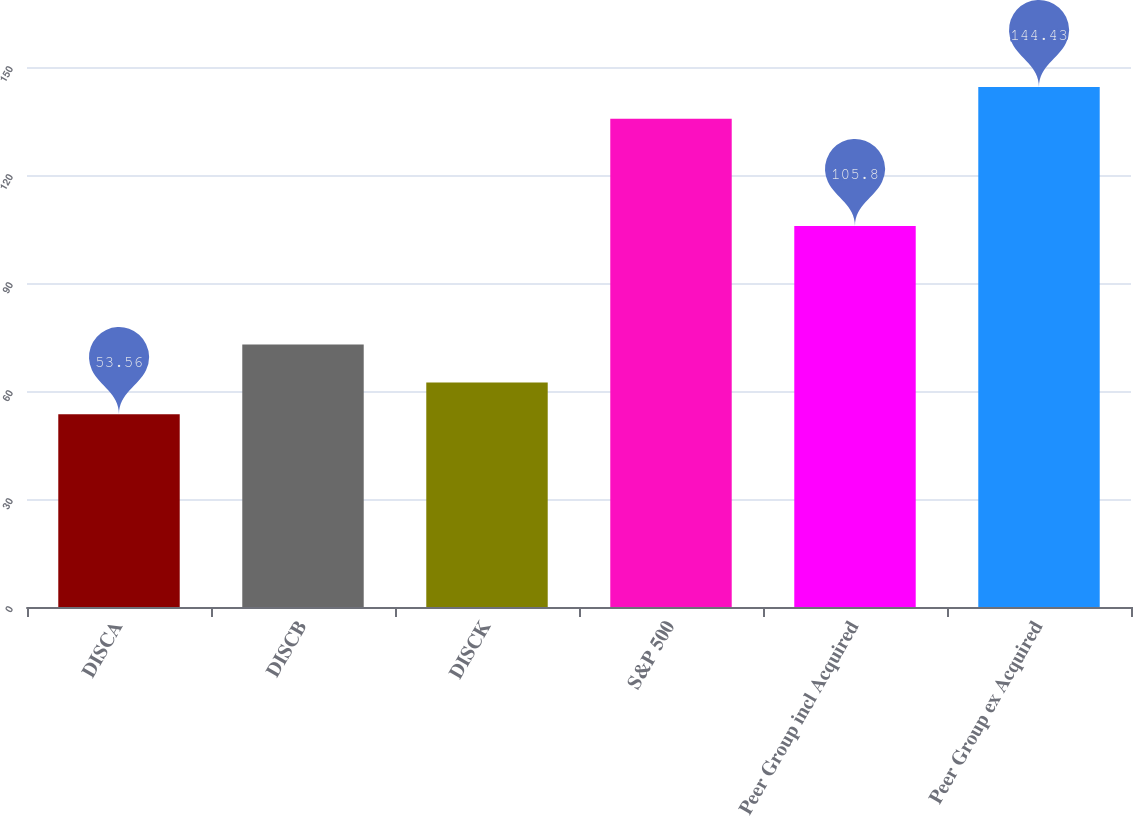Convert chart to OTSL. <chart><loc_0><loc_0><loc_500><loc_500><bar_chart><fcel>DISCA<fcel>DISCB<fcel>DISCK<fcel>S&P 500<fcel>Peer Group incl Acquired<fcel>Peer Group ex Acquired<nl><fcel>53.56<fcel>72.9<fcel>62.36<fcel>135.63<fcel>105.8<fcel>144.43<nl></chart> 